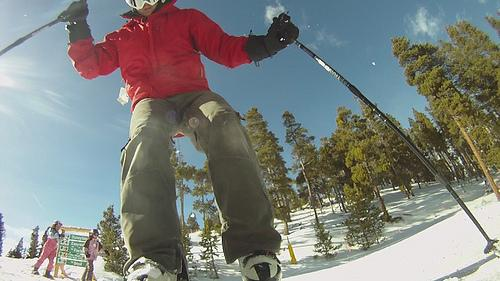Why does the person have poles? skiing 